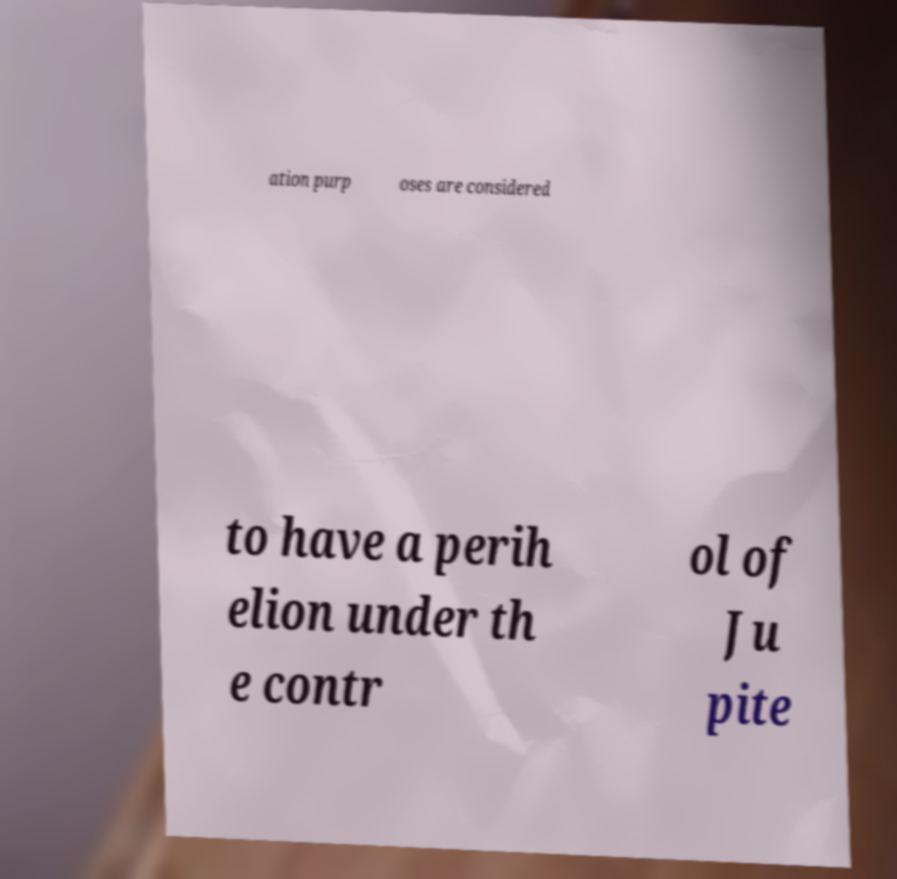Can you accurately transcribe the text from the provided image for me? ation purp oses are considered to have a perih elion under th e contr ol of Ju pite 